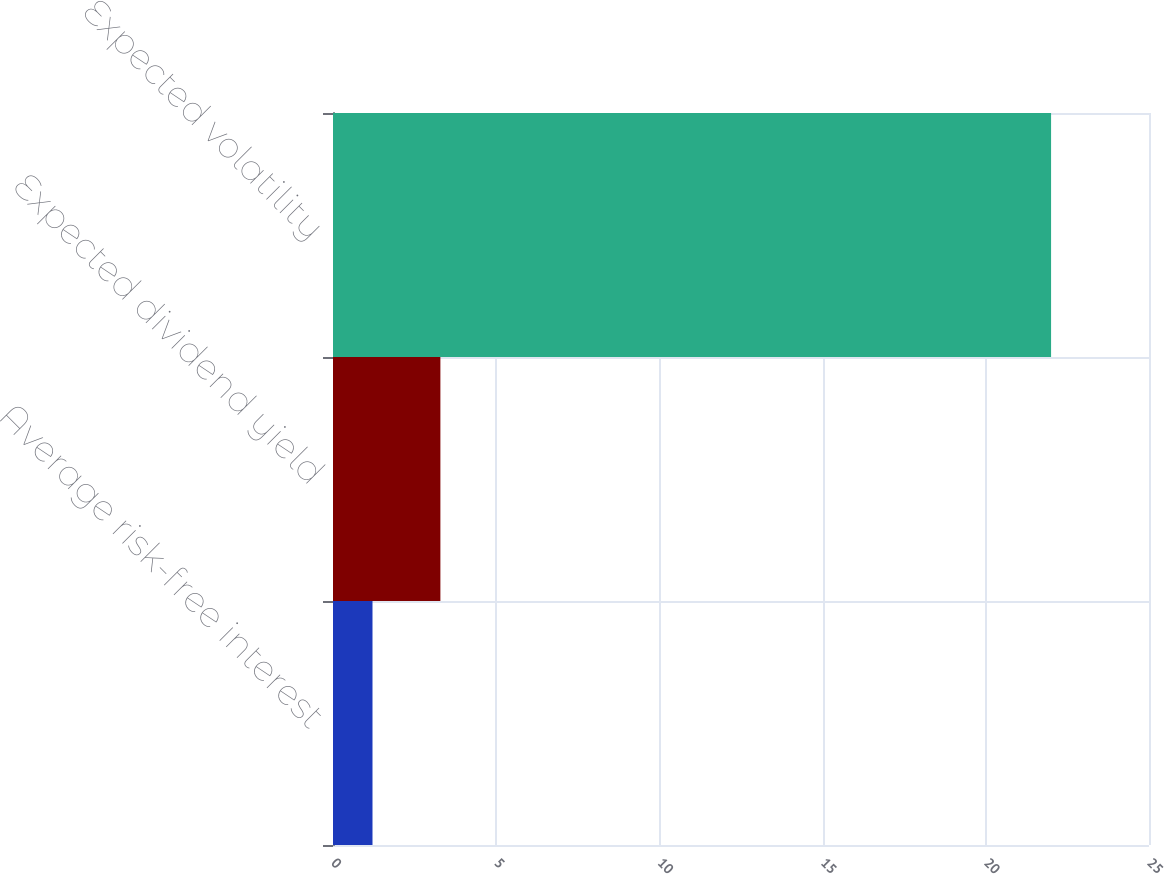Convert chart. <chart><loc_0><loc_0><loc_500><loc_500><bar_chart><fcel>Average risk-free interest<fcel>Expected dividend yield<fcel>Expected volatility<nl><fcel>1.21<fcel>3.29<fcel>22<nl></chart> 